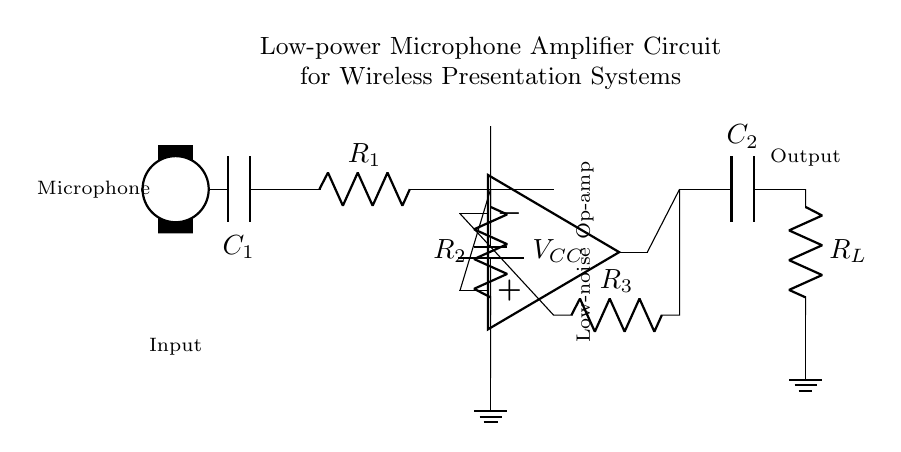What is the value of the input capacitor? The input capacitor, labeled as C1, appears directly after the microphone in the circuit diagram. There is no specific numerical value provided in the circuit details, suggesting it’s a generic placeholder.
Answer: C1 What type of amplifier is indicated in the circuit? The circuit includes a low-noise operational amplifier, which is explicitly noted in the schematic. It shows that it’s meant for enhancing the input signal from the microphone.
Answer: Low-noise op-amp What is the function of the capacitor labeled C2? C2 is positioned before the load resistor R_L and is typically used for coupling the output signal, allowing AC signals to pass while blocking any DC component, thus preserving audio quality.
Answer: Coupling How many resistors are present in this amplifier circuit? The diagram features three resistors labeled as R1, R2, and R3, which contribute to setting the gain and biasing of the circuit. They are connected in specific configurations to accomplish their roles within the amplifier.
Answer: Three What is the purpose of R_L in the circuit? R_L, labeled as the load resistor, is connected at the output and is essential for defining the output characteristics and impedance of the amplifier, thereby impacting the overall performance in the wireless presentation system.
Answer: Load resistor What is the power supply voltage denoted in the circuit? The power supply voltage, labeled V_CC, is indicated next to the battery symbol and typically provides the necessary power for the operational amplifier and other components in the circuit. However, a specific voltage value is not stated.
Answer: V_CC 